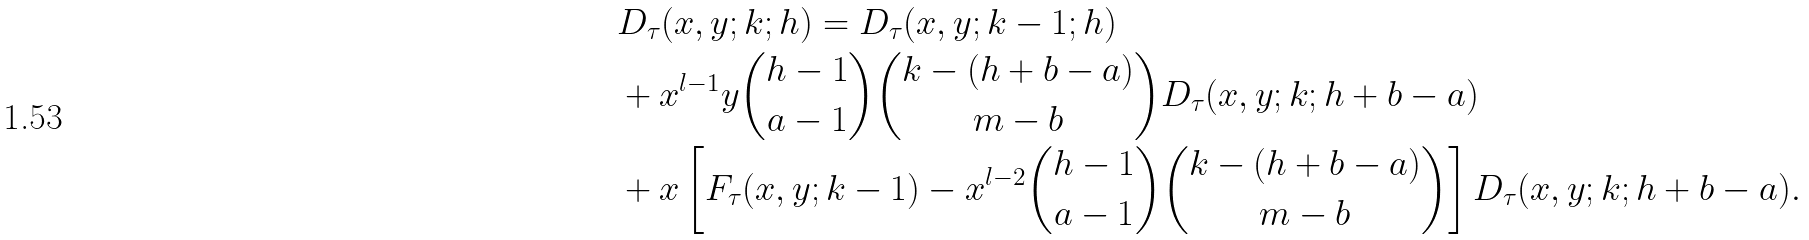Convert formula to latex. <formula><loc_0><loc_0><loc_500><loc_500>& D _ { \tau } ( x , y ; k ; h ) = D _ { \tau } ( x , y ; k - 1 ; h ) \\ & + x ^ { l - 1 } y \binom { h - 1 } { a - 1 } \binom { k - ( h + b - a ) } { m - b } D _ { \tau } ( x , y ; k ; h + b - a ) \\ & + x \left [ F _ { \tau } ( x , y ; k - 1 ) - x ^ { l - 2 } \binom { h - 1 } { a - 1 } \binom { k - ( h + b - a ) } { m - b } \right ] D _ { \tau } ( x , y ; k ; h + b - a ) .</formula> 